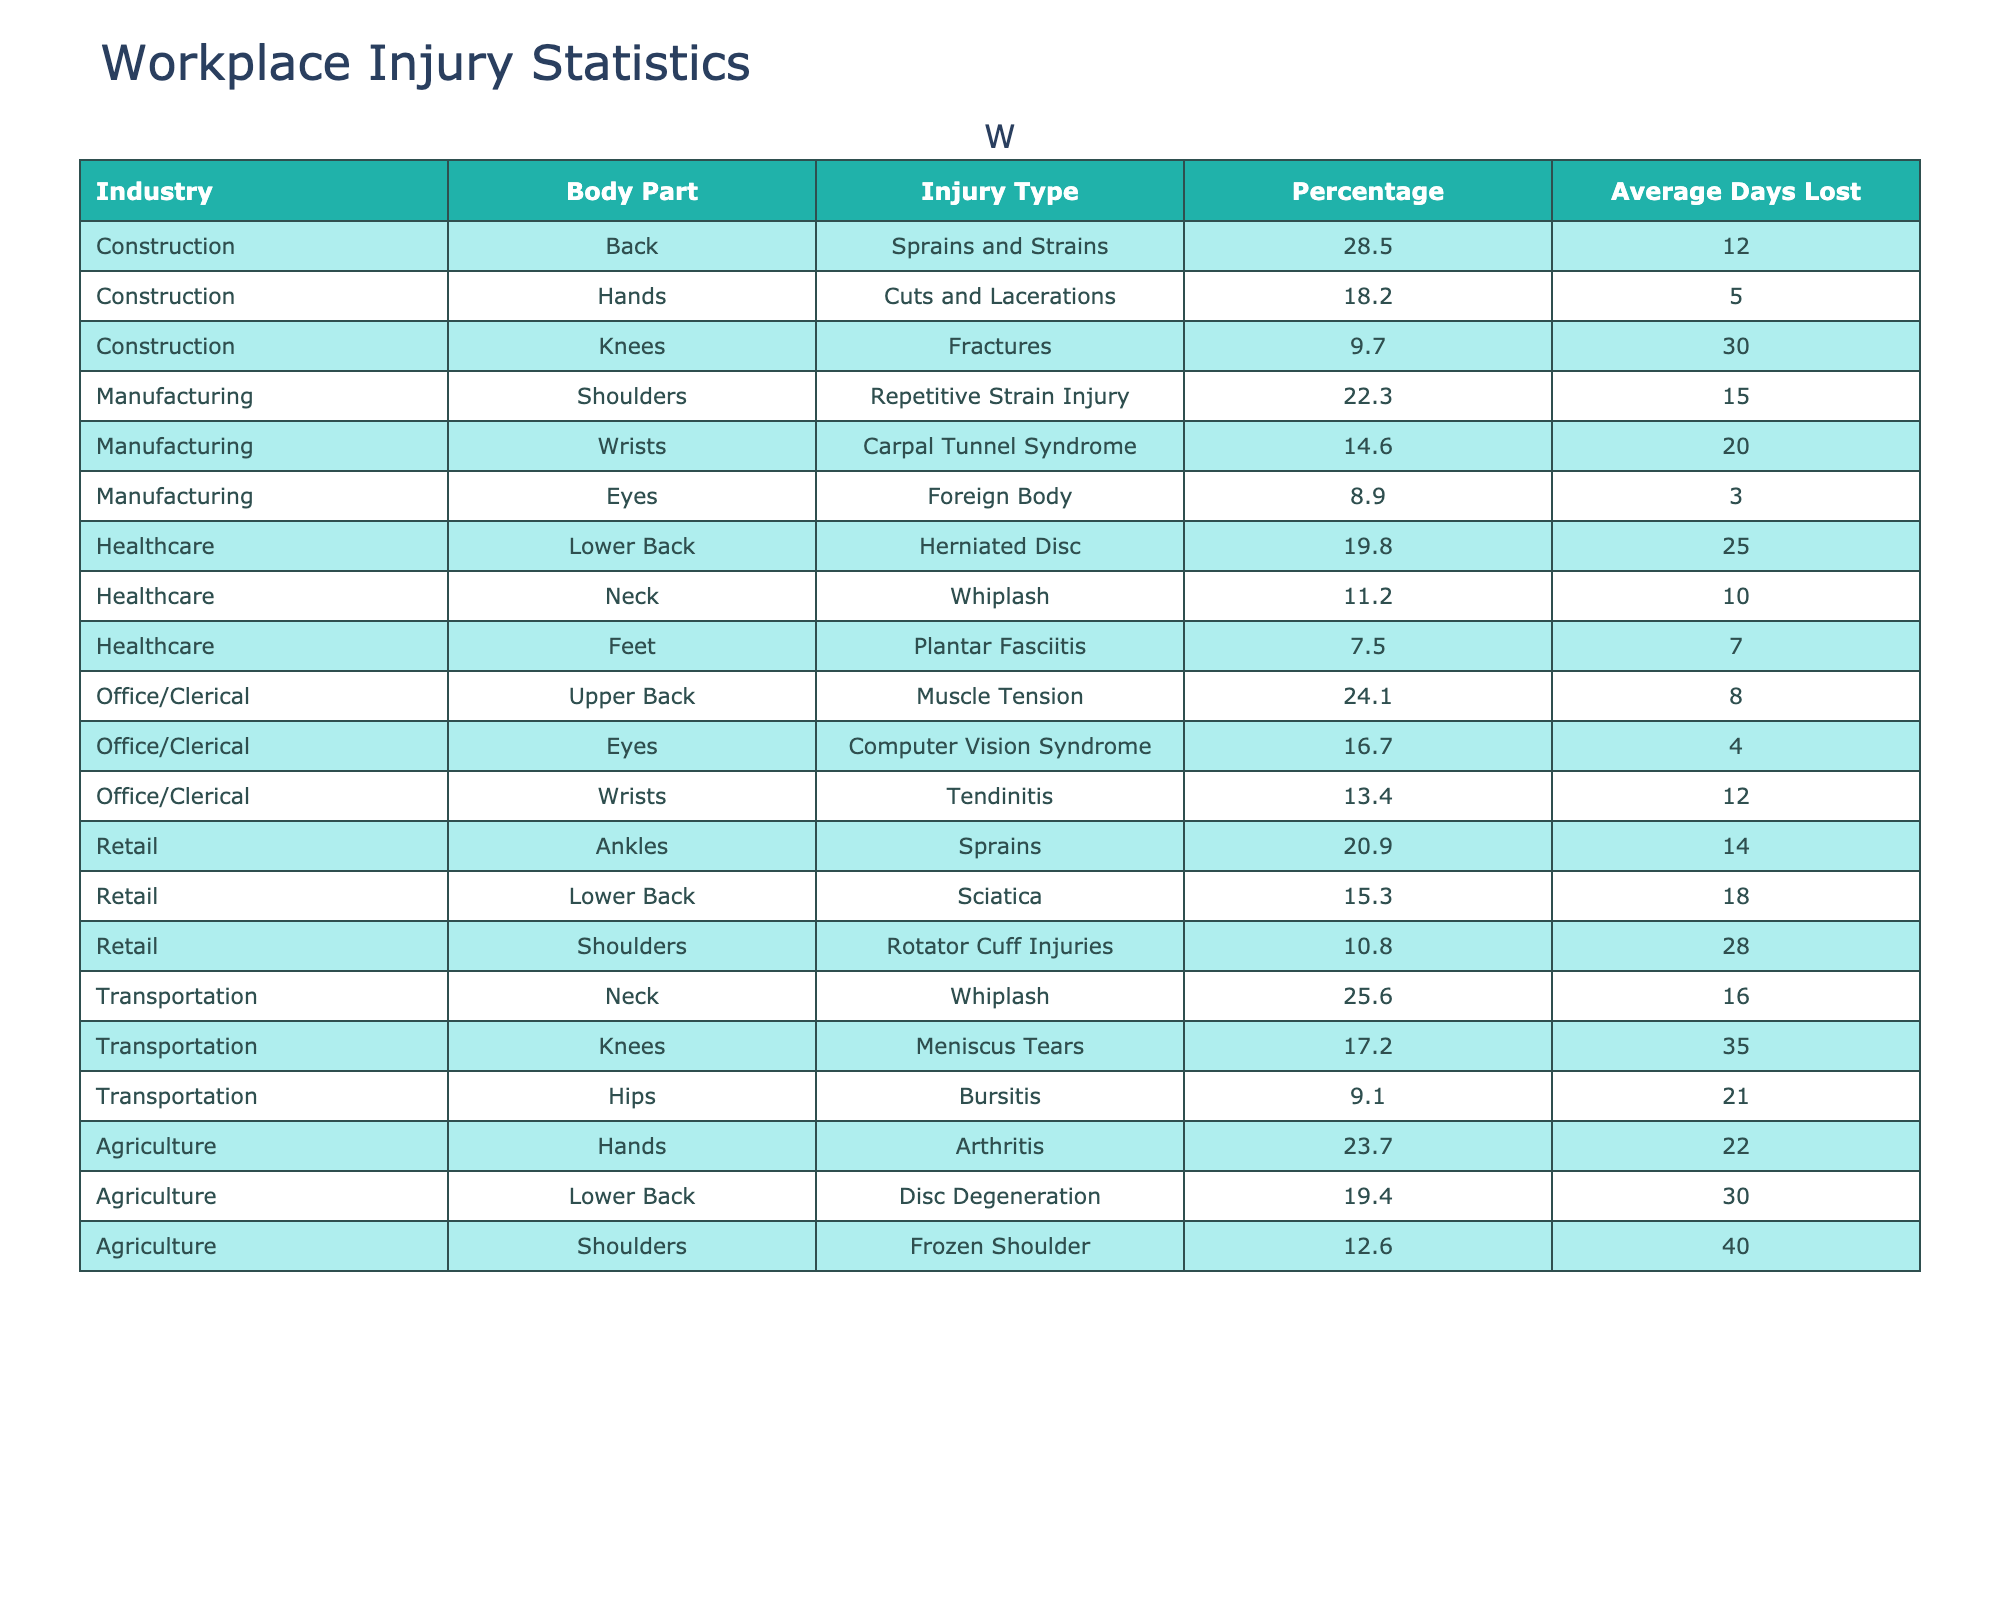What industry has the highest percentage of workplace injuries affecting the back? In the table, the percentage of injuries affecting the back in the Construction industry is 28.5%, which is the highest among all industries listed.
Answer: Construction What is the average number of days lost due to shoulder injuries in the manufacturing industry? The table shows that the average days lost for shoulder injuries (Repetitive Strain Injury, 22.3%) in Manufacturing is 15 days.
Answer: 15 Is there a body part with injuries in the Agriculture industry that has a higher average days lost than 20 days? Yes, the Shoulder injuries in the Agriculture industry (Frozen Shoulder) have an average of 40 days lost, which is greater than 20 days.
Answer: Yes Which injury type in the Retail industry has the highest percentage? The table indicates that Sprains affecting Ankles in the Retail industry have the highest percentage of 20.9%.
Answer: Sprains What is the total percentage of injuries for lower back issues across all industries? Adding the percentages: Healthcare (19.8%) + Retail (15.3%) + Agriculture (19.4%) gives a total of 54.5%.
Answer: 54.5% Which industry has the lowest percentage of injuries affecting the wrists? In the table, the Manufacturing industry (Carpal Tunnel Syndrome) has the lowest percentage affecting wrists at 14.6%.
Answer: Manufacturing Are injuries to the neck more common in the Healthcare industry than the Transportation industry? Yes, the percentage of neck injuries in the Healthcare industry (11.2%) is lower than in the Transportation industry (25.6%).
Answer: No What is the total average days lost for knee injuries across all listed industries? Summing the average days lost for knee injuries: Construction (30) + Manufacturing (0) + Healthcare (0) + Transportation (35) + Agriculture (0) gives a total of 65 days lost.
Answer: 65 Identify the body part that suffers from the highest percentage of injuries in the Office/Clerical industry. In the Office/Clerical industry, the highest percentage of injuries affects the Upper Back with 24.1%.
Answer: Upper Back If a preventive program reduced the average days lost for back injuries in the Construction industry by 50%, how many days would be lost on average? Halving the average days lost for back injuries, which is currently 12 days, results in 6 days.
Answer: 6 